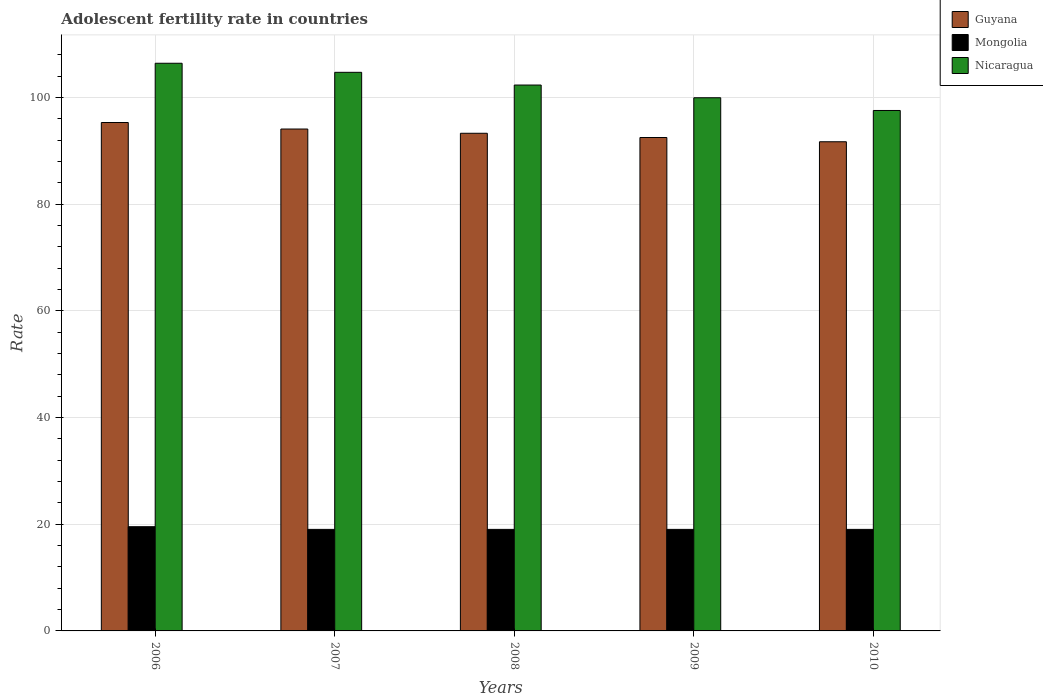How many different coloured bars are there?
Make the answer very short. 3. How many bars are there on the 1st tick from the left?
Your answer should be very brief. 3. What is the label of the 1st group of bars from the left?
Offer a very short reply. 2006. What is the adolescent fertility rate in Guyana in 2007?
Keep it short and to the point. 94.07. Across all years, what is the maximum adolescent fertility rate in Mongolia?
Keep it short and to the point. 19.54. Across all years, what is the minimum adolescent fertility rate in Nicaragua?
Offer a terse response. 97.55. In which year was the adolescent fertility rate in Guyana maximum?
Your answer should be very brief. 2006. What is the total adolescent fertility rate in Guyana in the graph?
Offer a very short reply. 466.82. What is the difference between the adolescent fertility rate in Nicaragua in 2006 and that in 2008?
Your answer should be very brief. 4.08. What is the difference between the adolescent fertility rate in Mongolia in 2009 and the adolescent fertility rate in Nicaragua in 2006?
Make the answer very short. -87.37. What is the average adolescent fertility rate in Nicaragua per year?
Keep it short and to the point. 102.18. In the year 2006, what is the difference between the adolescent fertility rate in Guyana and adolescent fertility rate in Mongolia?
Ensure brevity in your answer.  75.76. In how many years, is the adolescent fertility rate in Guyana greater than 40?
Your response must be concise. 5. What is the ratio of the adolescent fertility rate in Nicaragua in 2006 to that in 2007?
Offer a very short reply. 1.02. Is the adolescent fertility rate in Guyana in 2008 less than that in 2010?
Your response must be concise. No. What is the difference between the highest and the second highest adolescent fertility rate in Guyana?
Keep it short and to the point. 1.22. What is the difference between the highest and the lowest adolescent fertility rate in Guyana?
Offer a terse response. 3.61. Is the sum of the adolescent fertility rate in Mongolia in 2006 and 2008 greater than the maximum adolescent fertility rate in Nicaragua across all years?
Your answer should be compact. No. What does the 1st bar from the left in 2008 represents?
Provide a short and direct response. Guyana. What does the 3rd bar from the right in 2007 represents?
Provide a short and direct response. Guyana. Is it the case that in every year, the sum of the adolescent fertility rate in Mongolia and adolescent fertility rate in Nicaragua is greater than the adolescent fertility rate in Guyana?
Your answer should be compact. Yes. Are all the bars in the graph horizontal?
Your response must be concise. No. How many years are there in the graph?
Give a very brief answer. 5. What is the difference between two consecutive major ticks on the Y-axis?
Make the answer very short. 20. Where does the legend appear in the graph?
Your response must be concise. Top right. How many legend labels are there?
Offer a very short reply. 3. How are the legend labels stacked?
Your response must be concise. Vertical. What is the title of the graph?
Provide a short and direct response. Adolescent fertility rate in countries. Does "Fragile and conflict affected situations" appear as one of the legend labels in the graph?
Your answer should be compact. No. What is the label or title of the Y-axis?
Provide a succinct answer. Rate. What is the Rate in Guyana in 2006?
Make the answer very short. 95.3. What is the Rate of Mongolia in 2006?
Give a very brief answer. 19.54. What is the Rate of Nicaragua in 2006?
Provide a short and direct response. 106.4. What is the Rate of Guyana in 2007?
Your response must be concise. 94.07. What is the Rate in Mongolia in 2007?
Your answer should be compact. 19.03. What is the Rate of Nicaragua in 2007?
Give a very brief answer. 104.7. What is the Rate of Guyana in 2008?
Offer a terse response. 93.28. What is the Rate in Mongolia in 2008?
Give a very brief answer. 19.03. What is the Rate of Nicaragua in 2008?
Your answer should be very brief. 102.32. What is the Rate of Guyana in 2009?
Provide a succinct answer. 92.48. What is the Rate of Mongolia in 2009?
Your response must be concise. 19.03. What is the Rate of Nicaragua in 2009?
Keep it short and to the point. 99.94. What is the Rate of Guyana in 2010?
Provide a succinct answer. 91.69. What is the Rate in Mongolia in 2010?
Provide a succinct answer. 19.03. What is the Rate in Nicaragua in 2010?
Your answer should be compact. 97.55. Across all years, what is the maximum Rate in Guyana?
Make the answer very short. 95.3. Across all years, what is the maximum Rate in Mongolia?
Offer a terse response. 19.54. Across all years, what is the maximum Rate in Nicaragua?
Your response must be concise. 106.4. Across all years, what is the minimum Rate of Guyana?
Offer a very short reply. 91.69. Across all years, what is the minimum Rate of Mongolia?
Keep it short and to the point. 19.03. Across all years, what is the minimum Rate in Nicaragua?
Keep it short and to the point. 97.55. What is the total Rate of Guyana in the graph?
Your response must be concise. 466.82. What is the total Rate in Mongolia in the graph?
Provide a short and direct response. 95.66. What is the total Rate of Nicaragua in the graph?
Ensure brevity in your answer.  510.91. What is the difference between the Rate in Guyana in 2006 and that in 2007?
Make the answer very short. 1.22. What is the difference between the Rate of Mongolia in 2006 and that in 2007?
Keep it short and to the point. 0.5. What is the difference between the Rate of Nicaragua in 2006 and that in 2007?
Give a very brief answer. 1.7. What is the difference between the Rate of Guyana in 2006 and that in 2008?
Your answer should be very brief. 2.02. What is the difference between the Rate of Mongolia in 2006 and that in 2008?
Give a very brief answer. 0.5. What is the difference between the Rate in Nicaragua in 2006 and that in 2008?
Provide a succinct answer. 4.08. What is the difference between the Rate in Guyana in 2006 and that in 2009?
Your answer should be very brief. 2.81. What is the difference between the Rate of Mongolia in 2006 and that in 2009?
Provide a succinct answer. 0.5. What is the difference between the Rate of Nicaragua in 2006 and that in 2009?
Give a very brief answer. 6.47. What is the difference between the Rate of Guyana in 2006 and that in 2010?
Keep it short and to the point. 3.61. What is the difference between the Rate of Mongolia in 2006 and that in 2010?
Offer a terse response. 0.5. What is the difference between the Rate of Nicaragua in 2006 and that in 2010?
Offer a terse response. 8.85. What is the difference between the Rate of Guyana in 2007 and that in 2008?
Make the answer very short. 0.8. What is the difference between the Rate in Nicaragua in 2007 and that in 2008?
Give a very brief answer. 2.38. What is the difference between the Rate of Guyana in 2007 and that in 2009?
Your answer should be very brief. 1.59. What is the difference between the Rate in Mongolia in 2007 and that in 2009?
Make the answer very short. 0. What is the difference between the Rate of Nicaragua in 2007 and that in 2009?
Provide a short and direct response. 4.77. What is the difference between the Rate of Guyana in 2007 and that in 2010?
Your answer should be very brief. 2.38. What is the difference between the Rate of Mongolia in 2007 and that in 2010?
Make the answer very short. 0. What is the difference between the Rate of Nicaragua in 2007 and that in 2010?
Offer a terse response. 7.15. What is the difference between the Rate of Guyana in 2008 and that in 2009?
Your response must be concise. 0.8. What is the difference between the Rate in Mongolia in 2008 and that in 2009?
Make the answer very short. 0. What is the difference between the Rate of Nicaragua in 2008 and that in 2009?
Offer a very short reply. 2.38. What is the difference between the Rate of Guyana in 2008 and that in 2010?
Offer a very short reply. 1.59. What is the difference between the Rate of Mongolia in 2008 and that in 2010?
Provide a short and direct response. 0. What is the difference between the Rate in Nicaragua in 2008 and that in 2010?
Your response must be concise. 4.77. What is the difference between the Rate in Guyana in 2009 and that in 2010?
Ensure brevity in your answer.  0.8. What is the difference between the Rate in Mongolia in 2009 and that in 2010?
Provide a succinct answer. 0. What is the difference between the Rate in Nicaragua in 2009 and that in 2010?
Provide a short and direct response. 2.38. What is the difference between the Rate in Guyana in 2006 and the Rate in Mongolia in 2007?
Provide a short and direct response. 76.26. What is the difference between the Rate in Guyana in 2006 and the Rate in Nicaragua in 2007?
Your response must be concise. -9.41. What is the difference between the Rate in Mongolia in 2006 and the Rate in Nicaragua in 2007?
Your answer should be very brief. -85.17. What is the difference between the Rate of Guyana in 2006 and the Rate of Mongolia in 2008?
Offer a terse response. 76.26. What is the difference between the Rate in Guyana in 2006 and the Rate in Nicaragua in 2008?
Provide a succinct answer. -7.02. What is the difference between the Rate in Mongolia in 2006 and the Rate in Nicaragua in 2008?
Provide a short and direct response. -82.78. What is the difference between the Rate in Guyana in 2006 and the Rate in Mongolia in 2009?
Offer a terse response. 76.26. What is the difference between the Rate in Guyana in 2006 and the Rate in Nicaragua in 2009?
Your answer should be compact. -4.64. What is the difference between the Rate in Mongolia in 2006 and the Rate in Nicaragua in 2009?
Keep it short and to the point. -80.4. What is the difference between the Rate in Guyana in 2006 and the Rate in Mongolia in 2010?
Make the answer very short. 76.26. What is the difference between the Rate of Guyana in 2006 and the Rate of Nicaragua in 2010?
Give a very brief answer. -2.26. What is the difference between the Rate of Mongolia in 2006 and the Rate of Nicaragua in 2010?
Your answer should be very brief. -78.02. What is the difference between the Rate of Guyana in 2007 and the Rate of Mongolia in 2008?
Give a very brief answer. 75.04. What is the difference between the Rate of Guyana in 2007 and the Rate of Nicaragua in 2008?
Provide a short and direct response. -8.25. What is the difference between the Rate of Mongolia in 2007 and the Rate of Nicaragua in 2008?
Provide a succinct answer. -83.29. What is the difference between the Rate of Guyana in 2007 and the Rate of Mongolia in 2009?
Ensure brevity in your answer.  75.04. What is the difference between the Rate in Guyana in 2007 and the Rate in Nicaragua in 2009?
Offer a terse response. -5.86. What is the difference between the Rate of Mongolia in 2007 and the Rate of Nicaragua in 2009?
Provide a succinct answer. -80.9. What is the difference between the Rate of Guyana in 2007 and the Rate of Mongolia in 2010?
Make the answer very short. 75.04. What is the difference between the Rate of Guyana in 2007 and the Rate of Nicaragua in 2010?
Make the answer very short. -3.48. What is the difference between the Rate of Mongolia in 2007 and the Rate of Nicaragua in 2010?
Your answer should be very brief. -78.52. What is the difference between the Rate in Guyana in 2008 and the Rate in Mongolia in 2009?
Offer a terse response. 74.25. What is the difference between the Rate in Guyana in 2008 and the Rate in Nicaragua in 2009?
Keep it short and to the point. -6.66. What is the difference between the Rate of Mongolia in 2008 and the Rate of Nicaragua in 2009?
Provide a succinct answer. -80.9. What is the difference between the Rate of Guyana in 2008 and the Rate of Mongolia in 2010?
Your answer should be very brief. 74.25. What is the difference between the Rate in Guyana in 2008 and the Rate in Nicaragua in 2010?
Offer a very short reply. -4.27. What is the difference between the Rate of Mongolia in 2008 and the Rate of Nicaragua in 2010?
Make the answer very short. -78.52. What is the difference between the Rate in Guyana in 2009 and the Rate in Mongolia in 2010?
Your response must be concise. 73.45. What is the difference between the Rate in Guyana in 2009 and the Rate in Nicaragua in 2010?
Your answer should be compact. -5.07. What is the difference between the Rate of Mongolia in 2009 and the Rate of Nicaragua in 2010?
Your answer should be compact. -78.52. What is the average Rate in Guyana per year?
Provide a succinct answer. 93.36. What is the average Rate of Mongolia per year?
Provide a short and direct response. 19.13. What is the average Rate of Nicaragua per year?
Your answer should be compact. 102.18. In the year 2006, what is the difference between the Rate in Guyana and Rate in Mongolia?
Your response must be concise. 75.76. In the year 2006, what is the difference between the Rate in Guyana and Rate in Nicaragua?
Offer a very short reply. -11.11. In the year 2006, what is the difference between the Rate in Mongolia and Rate in Nicaragua?
Give a very brief answer. -86.87. In the year 2007, what is the difference between the Rate of Guyana and Rate of Mongolia?
Ensure brevity in your answer.  75.04. In the year 2007, what is the difference between the Rate of Guyana and Rate of Nicaragua?
Provide a short and direct response. -10.63. In the year 2007, what is the difference between the Rate in Mongolia and Rate in Nicaragua?
Keep it short and to the point. -85.67. In the year 2008, what is the difference between the Rate in Guyana and Rate in Mongolia?
Give a very brief answer. 74.25. In the year 2008, what is the difference between the Rate in Guyana and Rate in Nicaragua?
Provide a short and direct response. -9.04. In the year 2008, what is the difference between the Rate in Mongolia and Rate in Nicaragua?
Provide a succinct answer. -83.29. In the year 2009, what is the difference between the Rate of Guyana and Rate of Mongolia?
Your answer should be very brief. 73.45. In the year 2009, what is the difference between the Rate of Guyana and Rate of Nicaragua?
Your answer should be compact. -7.45. In the year 2009, what is the difference between the Rate of Mongolia and Rate of Nicaragua?
Your answer should be very brief. -80.9. In the year 2010, what is the difference between the Rate of Guyana and Rate of Mongolia?
Keep it short and to the point. 72.66. In the year 2010, what is the difference between the Rate of Guyana and Rate of Nicaragua?
Ensure brevity in your answer.  -5.86. In the year 2010, what is the difference between the Rate in Mongolia and Rate in Nicaragua?
Your response must be concise. -78.52. What is the ratio of the Rate in Guyana in 2006 to that in 2007?
Offer a terse response. 1.01. What is the ratio of the Rate in Mongolia in 2006 to that in 2007?
Your answer should be compact. 1.03. What is the ratio of the Rate of Nicaragua in 2006 to that in 2007?
Give a very brief answer. 1.02. What is the ratio of the Rate of Guyana in 2006 to that in 2008?
Give a very brief answer. 1.02. What is the ratio of the Rate of Mongolia in 2006 to that in 2008?
Give a very brief answer. 1.03. What is the ratio of the Rate in Nicaragua in 2006 to that in 2008?
Your response must be concise. 1.04. What is the ratio of the Rate of Guyana in 2006 to that in 2009?
Your answer should be compact. 1.03. What is the ratio of the Rate in Mongolia in 2006 to that in 2009?
Your answer should be very brief. 1.03. What is the ratio of the Rate of Nicaragua in 2006 to that in 2009?
Give a very brief answer. 1.06. What is the ratio of the Rate in Guyana in 2006 to that in 2010?
Keep it short and to the point. 1.04. What is the ratio of the Rate in Mongolia in 2006 to that in 2010?
Your answer should be compact. 1.03. What is the ratio of the Rate in Nicaragua in 2006 to that in 2010?
Keep it short and to the point. 1.09. What is the ratio of the Rate of Guyana in 2007 to that in 2008?
Offer a very short reply. 1.01. What is the ratio of the Rate of Mongolia in 2007 to that in 2008?
Offer a very short reply. 1. What is the ratio of the Rate of Nicaragua in 2007 to that in 2008?
Provide a short and direct response. 1.02. What is the ratio of the Rate of Guyana in 2007 to that in 2009?
Make the answer very short. 1.02. What is the ratio of the Rate in Mongolia in 2007 to that in 2009?
Make the answer very short. 1. What is the ratio of the Rate of Nicaragua in 2007 to that in 2009?
Provide a short and direct response. 1.05. What is the ratio of the Rate in Guyana in 2007 to that in 2010?
Your response must be concise. 1.03. What is the ratio of the Rate in Mongolia in 2007 to that in 2010?
Your answer should be very brief. 1. What is the ratio of the Rate in Nicaragua in 2007 to that in 2010?
Give a very brief answer. 1.07. What is the ratio of the Rate of Guyana in 2008 to that in 2009?
Give a very brief answer. 1.01. What is the ratio of the Rate of Mongolia in 2008 to that in 2009?
Offer a terse response. 1. What is the ratio of the Rate of Nicaragua in 2008 to that in 2009?
Provide a succinct answer. 1.02. What is the ratio of the Rate in Guyana in 2008 to that in 2010?
Offer a terse response. 1.02. What is the ratio of the Rate in Mongolia in 2008 to that in 2010?
Keep it short and to the point. 1. What is the ratio of the Rate in Nicaragua in 2008 to that in 2010?
Give a very brief answer. 1.05. What is the ratio of the Rate of Guyana in 2009 to that in 2010?
Provide a short and direct response. 1.01. What is the ratio of the Rate of Nicaragua in 2009 to that in 2010?
Make the answer very short. 1.02. What is the difference between the highest and the second highest Rate in Guyana?
Your answer should be compact. 1.22. What is the difference between the highest and the second highest Rate in Mongolia?
Provide a succinct answer. 0.5. What is the difference between the highest and the second highest Rate of Nicaragua?
Make the answer very short. 1.7. What is the difference between the highest and the lowest Rate in Guyana?
Offer a very short reply. 3.61. What is the difference between the highest and the lowest Rate of Mongolia?
Provide a short and direct response. 0.5. What is the difference between the highest and the lowest Rate in Nicaragua?
Provide a succinct answer. 8.85. 